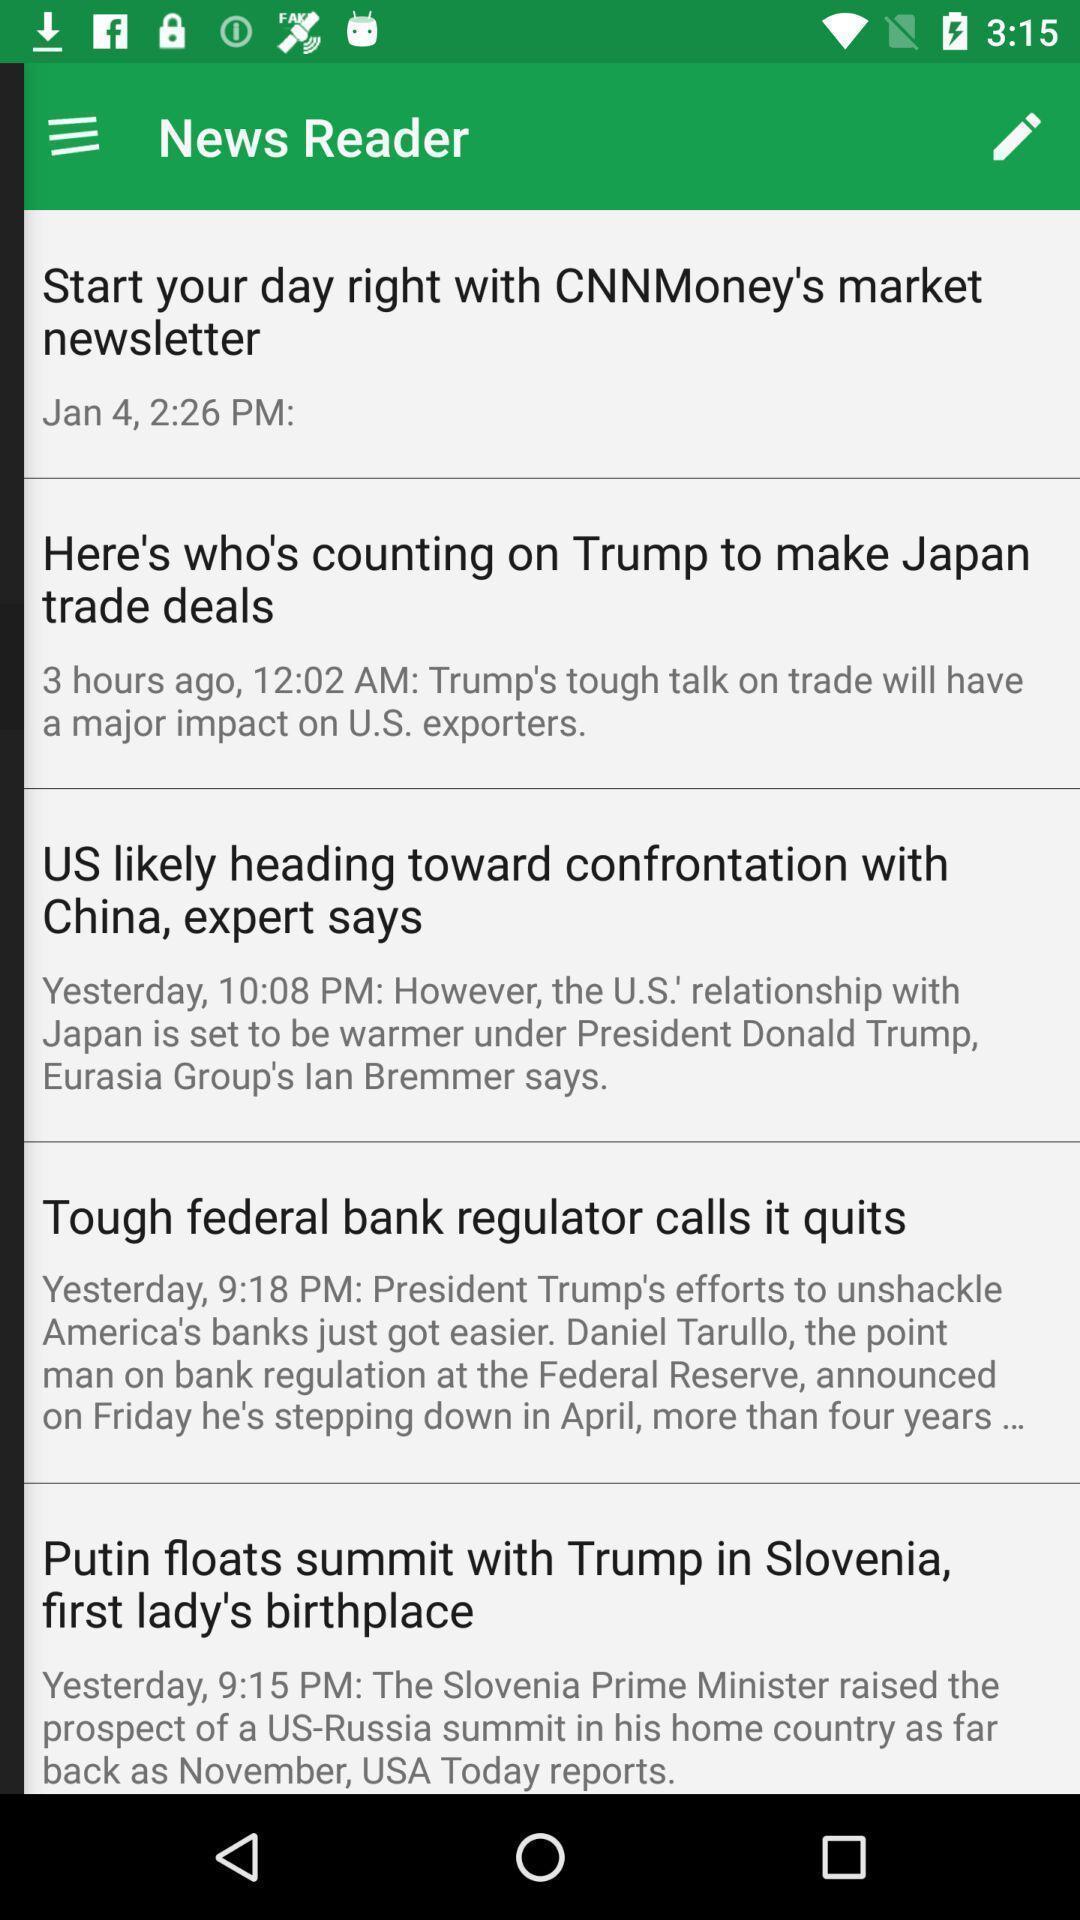Describe the key features of this screenshot. Screen displaying the list of news letters. 